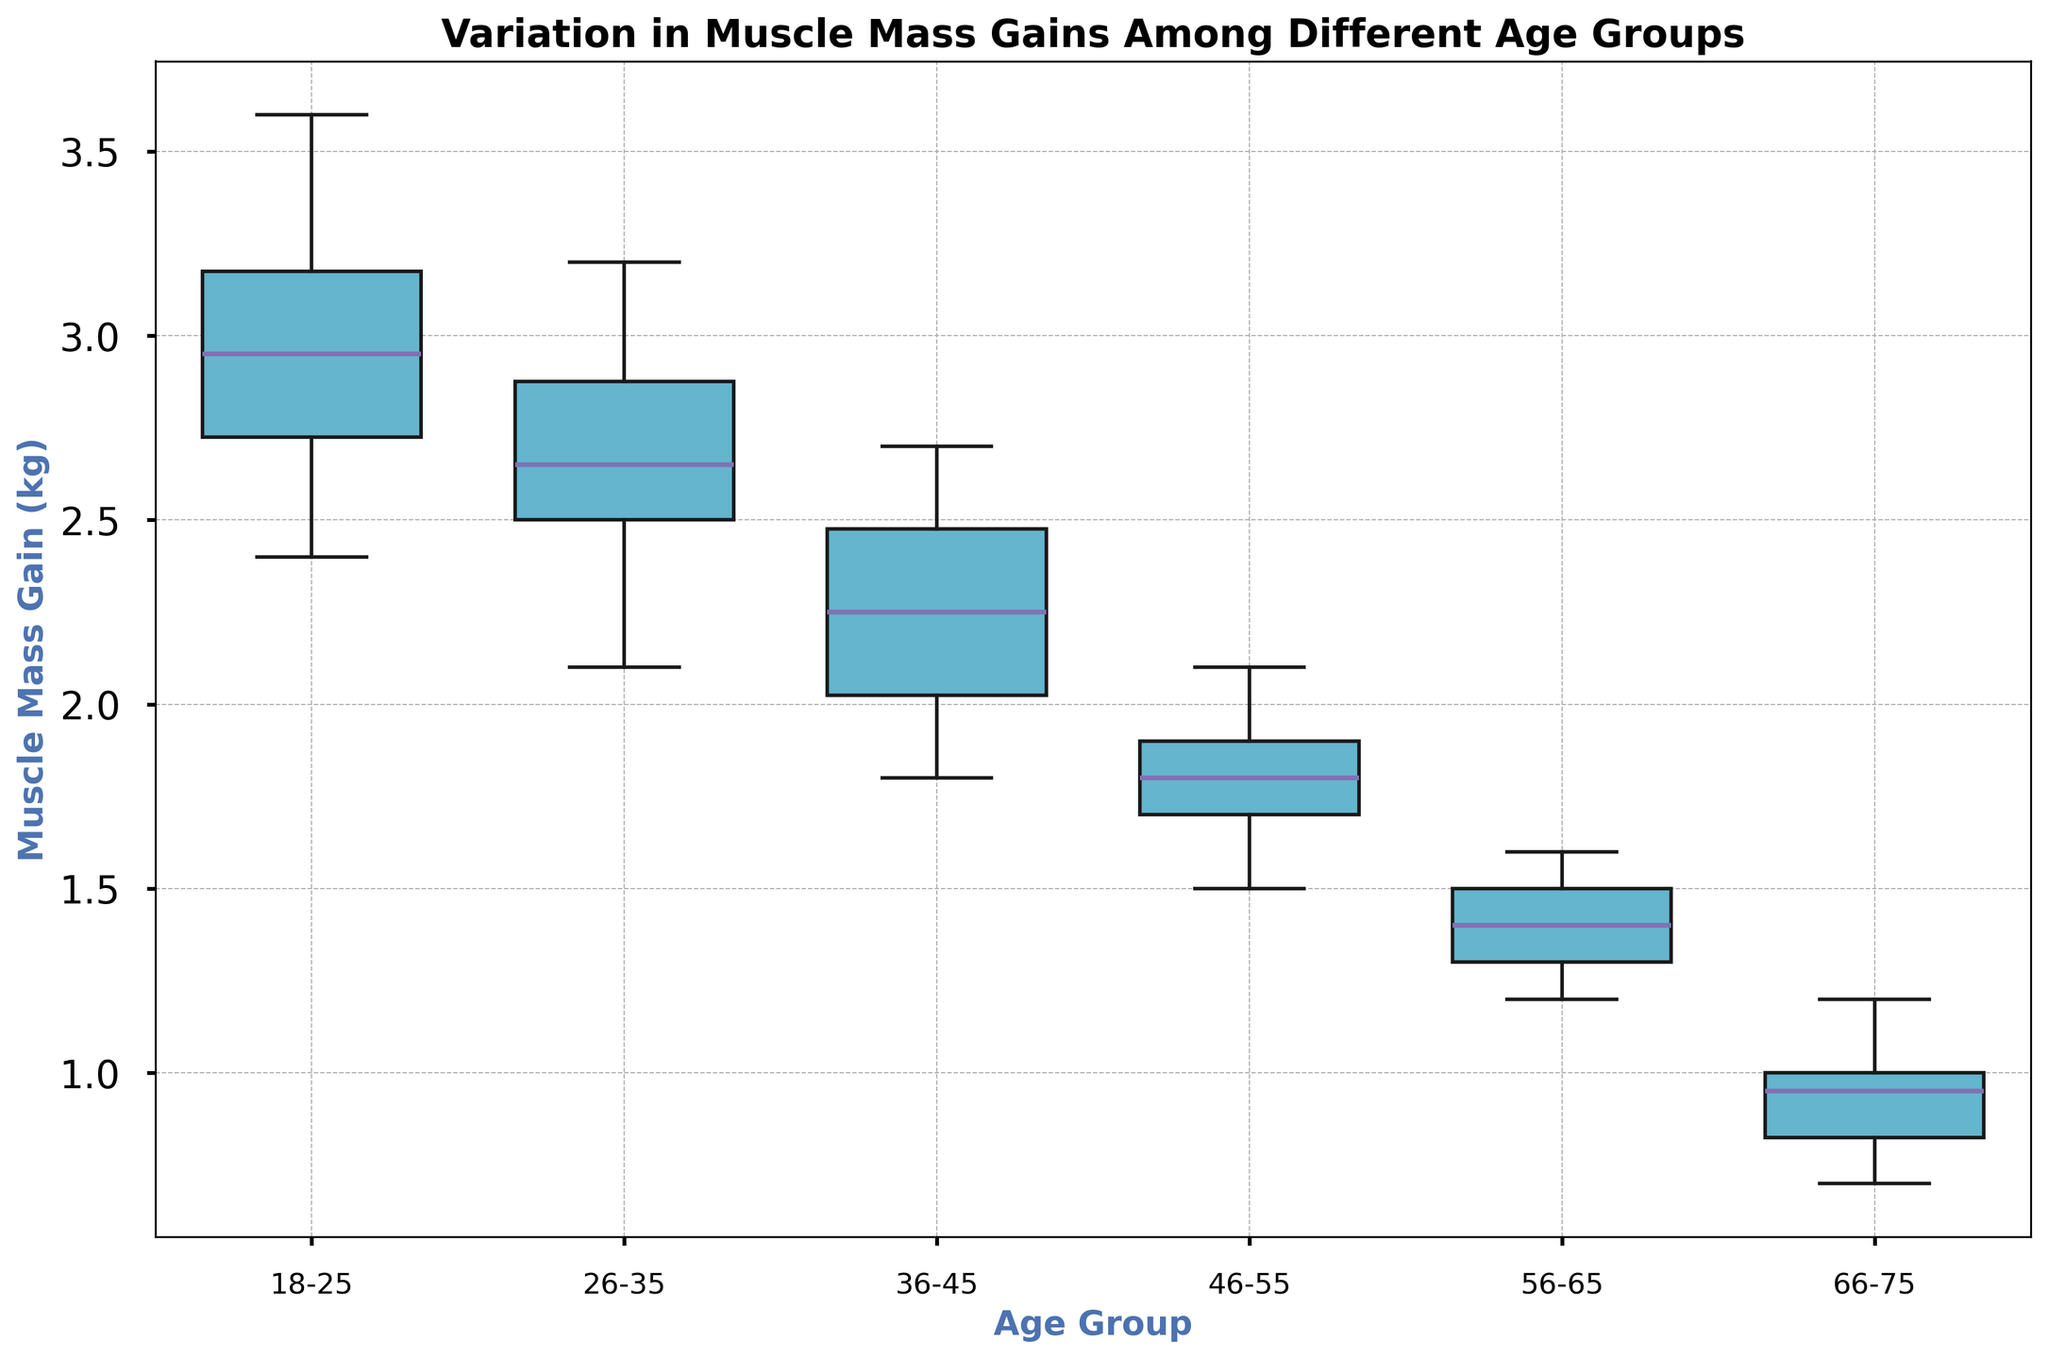What's the median muscle mass gain for the 18-25 age group? Locate the 18-25 box plot on the x-axis. The median is the line inside the box; visually inspect the height of this line.
Answer: 3.0 In which age group is the variation in muscle mass gain the largest? Compare the length of the boxes (interquartile range, IQR) across all age groups; the wider the box, the higher the variation.
Answer: 18-25 Which age group has the lowest median muscle mass gain? Find the box plot with the lowest median line (in the center of the box).
Answer: 66-75 Are there any outliers in the muscle mass gain data for any age group? Look for any points outside the whiskers (lines extending from the box).
Answer: Yes What is the interquartile range (IQR) for the 36-45 age group? Identify the top and bottom of the box for the 36-45 age group. The IQR is the difference between these two values.
Answer: 0.6 How does the median muscle mass gain for 26-35 compare to 56-65? Find the median lines for both age groups. Visually compare their heights.
Answer: Higher for 26-35 Which age group has the most consistent muscle mass gain? Look for the box plot with the smallest interquartile range (IQR).
Answer: 66-75 What is the range of muscle mass gain for the 46-55 age group? Identify the maximum and minimum points (whisker ends) and subtract the minimum from the maximum.
Answer: 0.6 What is the median difference in muscle mass gain between 36-45 and 46-55 age groups? Find the median lines for both age groups and subtract the median of 46-55 from 36-45.
Answer: 0.4 Does the muscle mass gain generally decrease with age? Observe the medians and IQRs across the age groups from youngest to oldest to see if there's a downward trend.
Answer: Yes 